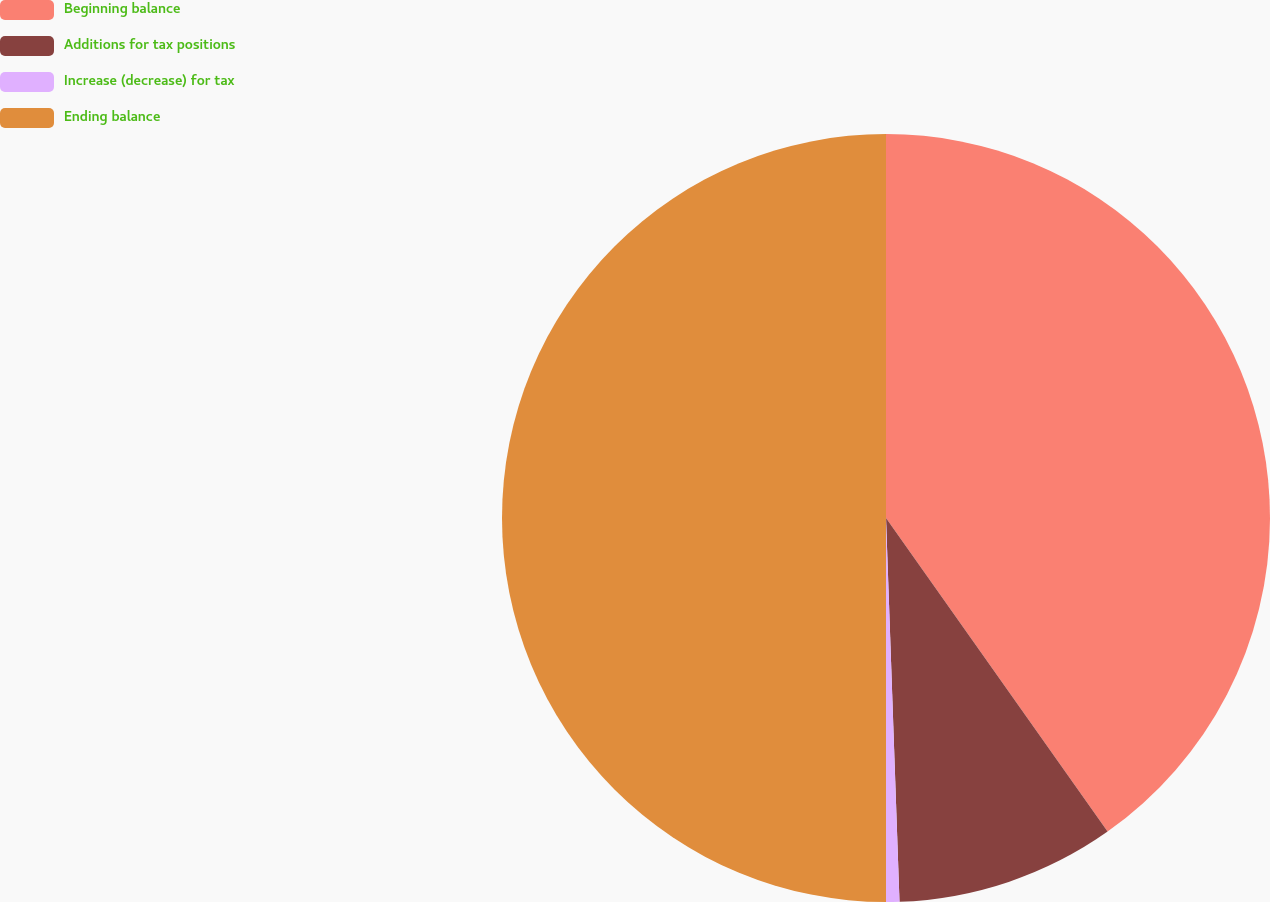<chart> <loc_0><loc_0><loc_500><loc_500><pie_chart><fcel>Beginning balance<fcel>Additions for tax positions<fcel>Increase (decrease) for tax<fcel>Ending balance<nl><fcel>40.21%<fcel>9.23%<fcel>0.56%<fcel>50.0%<nl></chart> 